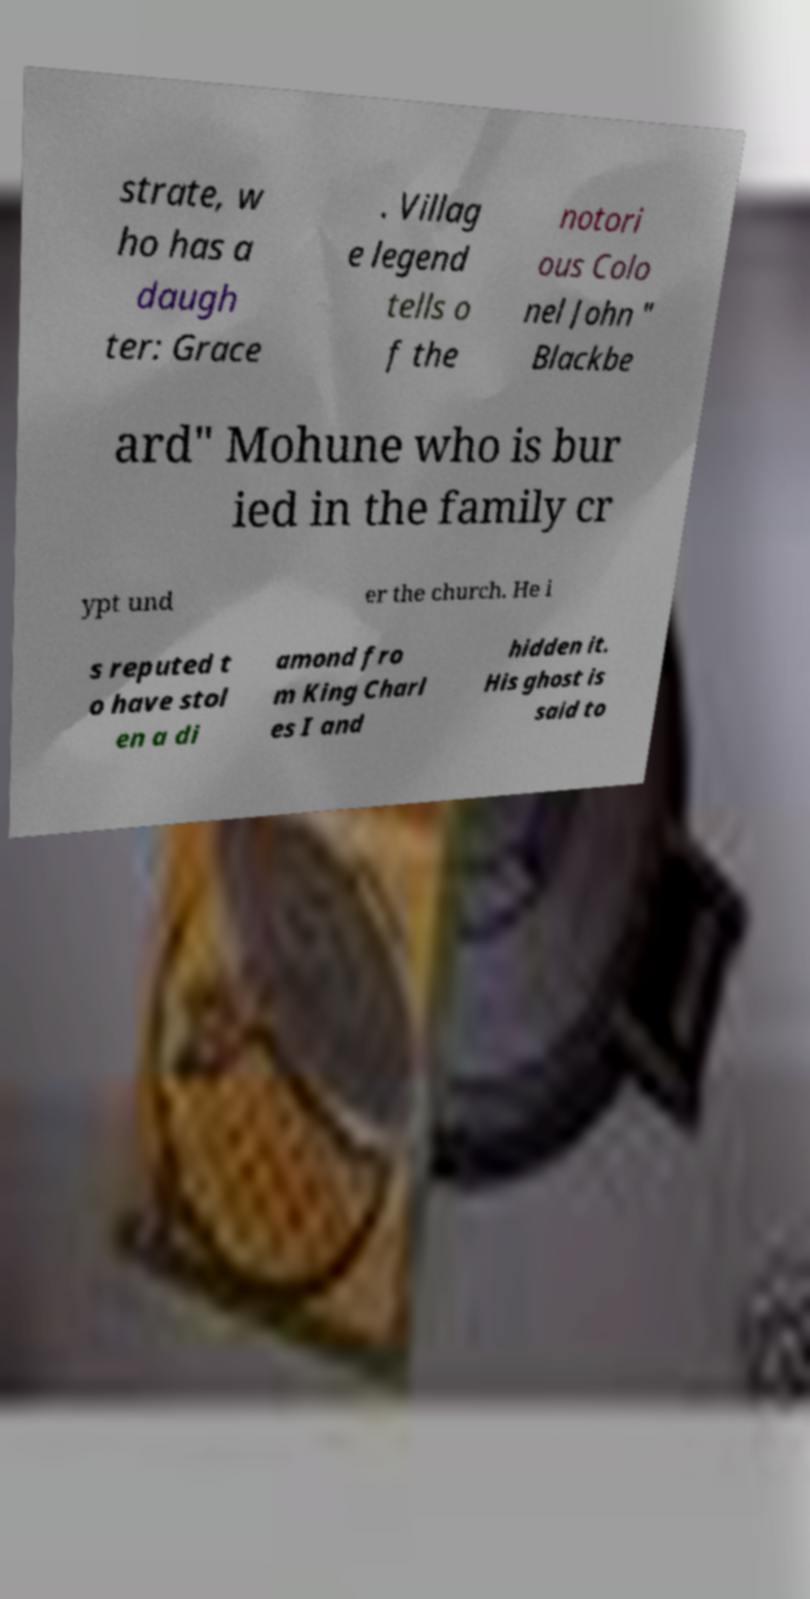Could you assist in decoding the text presented in this image and type it out clearly? strate, w ho has a daugh ter: Grace . Villag e legend tells o f the notori ous Colo nel John " Blackbe ard" Mohune who is bur ied in the family cr ypt und er the church. He i s reputed t o have stol en a di amond fro m King Charl es I and hidden it. His ghost is said to 